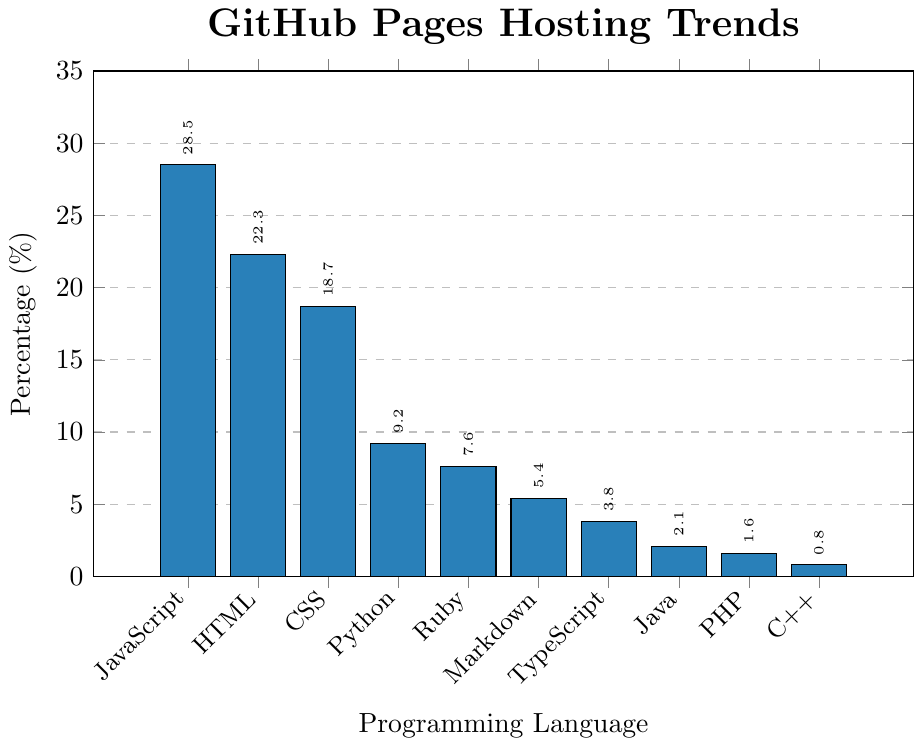What programming language has the highest percentage of GitHub Pages hosting? The figure shows a bar chart representing the percentage of GitHub Pages hosting across different programming languages. The tallest bar represents JavaScript at 28.5%.
Answer: JavaScript Which programming language has the smallest percentage of GitHub Pages hosting? The chart presents the lowest bar in the data, which is associated with C++ at 0.8%.
Answer: C++ What is the combined percentage of HTML and CSS for GitHub Pages hosting? The individual percentages for HTML and CSS are 22.3% and 18.7%. Adding these values together gives 22.3 + 18.7 = 41.0%.
Answer: 41.0% How much higher is the percentage of JavaScript compared to Python? JavaScript has 28.5% while Python has 9.2%. Therefore, the difference is 28.5 - 9.2 = 19.3%.
Answer: 19.3% Rank the top three programming languages by the percentage of GitHub Pages hosting. By examining the height of the bars and the corresponding percentages, the top three languages are JavaScript (28.5%), HTML (22.3%), and CSS (18.7%).
Answer: JavaScript, HTML, CSS What is the difference in hosting percentage between the highest and the lowest programming languages? The highest percentage is for JavaScript at 28.5%, and the lowest is for C++ at 0.8%. Therefore, the difference is 28.5 - 0.8 = 27.7%.
Answer: 27.7% What percentage of GitHub Pages hosting is attributed to Python and Ruby combined? The combined percentage for Python and Ruby is calculated by adding their respective values: 9.2% for Python and 7.6% for Ruby. Thus, 9.2 + 7.6 = 16.8%.
Answer: 16.8% Which programming language has nearly half the hosting percentage of HTML? HTML has a hosting percentage of 22.3%. To find nearly half, compute 22.3 / 2 ≈ 11.15. Python has a percentage close to this value at 9.2%.
Answer: Python How does the hosting percentage for TypeScript compare to that of PHP? TypeScript has a percentage of 3.8%, and PHP has 1.6%. By comparing, TypeScript is greater than PHP by 3.8 - 1.6 = 2.2%.
Answer: TypeScript is 2.2% higher than PHP 